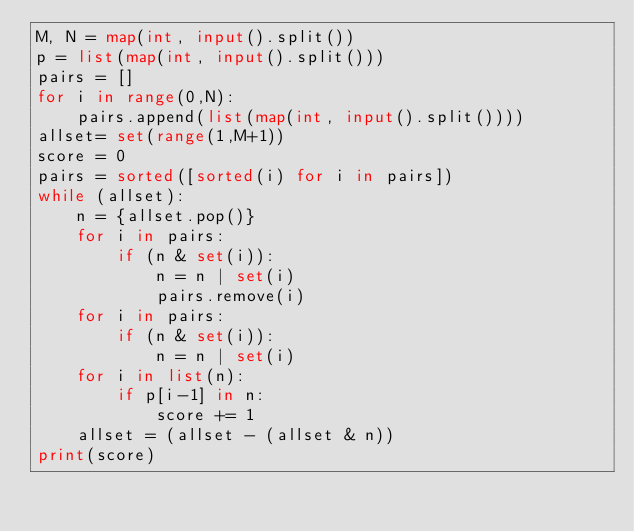Convert code to text. <code><loc_0><loc_0><loc_500><loc_500><_Python_>M, N = map(int, input().split())
p = list(map(int, input().split()))
pairs = []
for i in range(0,N):
    pairs.append(list(map(int, input().split())))
allset= set(range(1,M+1))
score = 0
pairs = sorted([sorted(i) for i in pairs])
while (allset):
    n = {allset.pop()}
    for i in pairs:
        if (n & set(i)):
            n = n | set(i)
            pairs.remove(i)
    for i in pairs:
        if (n & set(i)):
            n = n | set(i)
    for i in list(n):
        if p[i-1] in n:
            score += 1
    allset = (allset - (allset & n))
print(score)</code> 